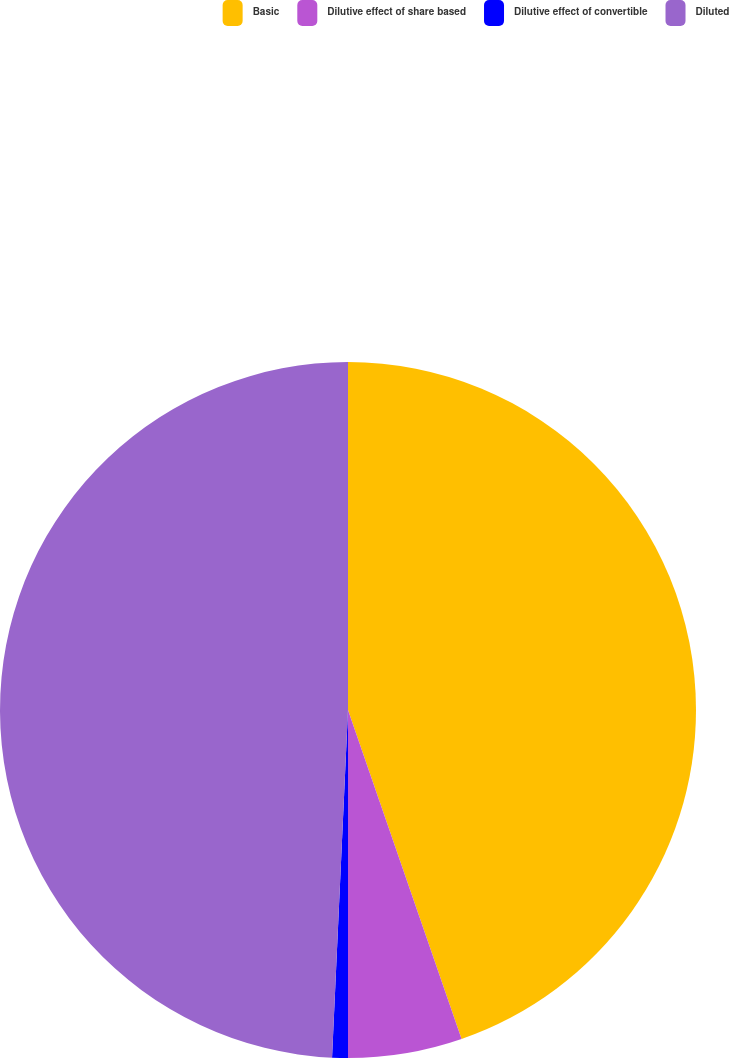<chart> <loc_0><loc_0><loc_500><loc_500><pie_chart><fcel>Basic<fcel>Dilutive effect of share based<fcel>Dilutive effect of convertible<fcel>Diluted<nl><fcel>44.71%<fcel>5.29%<fcel>0.73%<fcel>49.27%<nl></chart> 